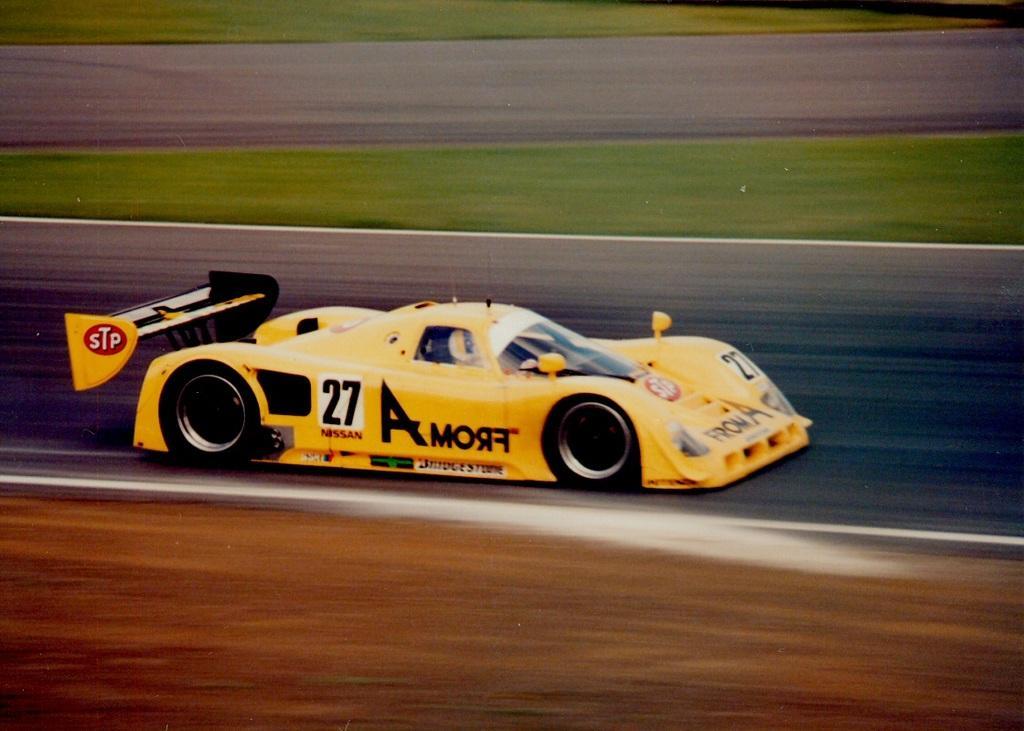Can you describe this image briefly? In this image I can see a race car. And the background is blurry. 